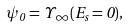<formula> <loc_0><loc_0><loc_500><loc_500>\psi _ { 0 } = \Upsilon _ { \infty } ( E _ { s } = 0 ) ,</formula> 